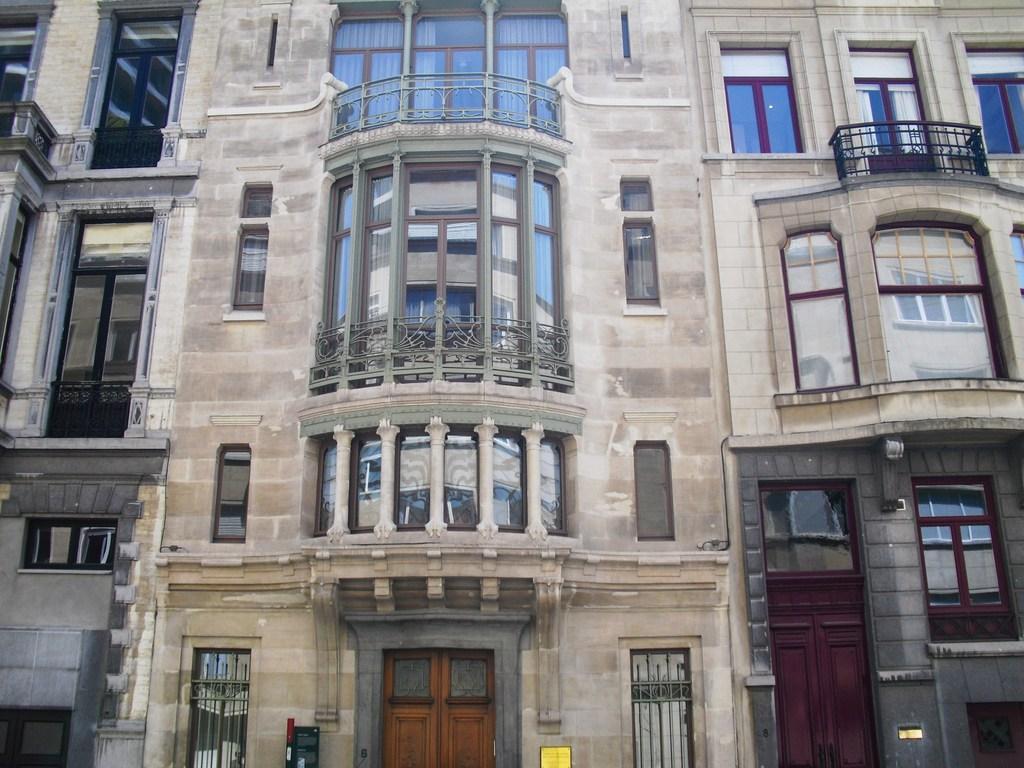Can you describe this image briefly? In this picture we can see a building, windows, railings, doors and boards. 